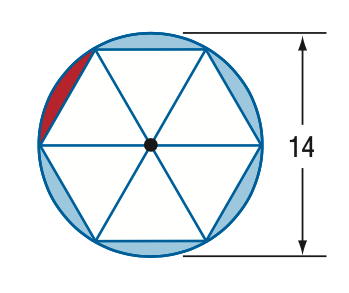Question: A regular hexagon is inscribed in a circle with a diameter of 14. Find the area of the red segment.
Choices:
A. 4.44
B. 8.88
C. 21.22
D. 25.66
Answer with the letter. Answer: A 